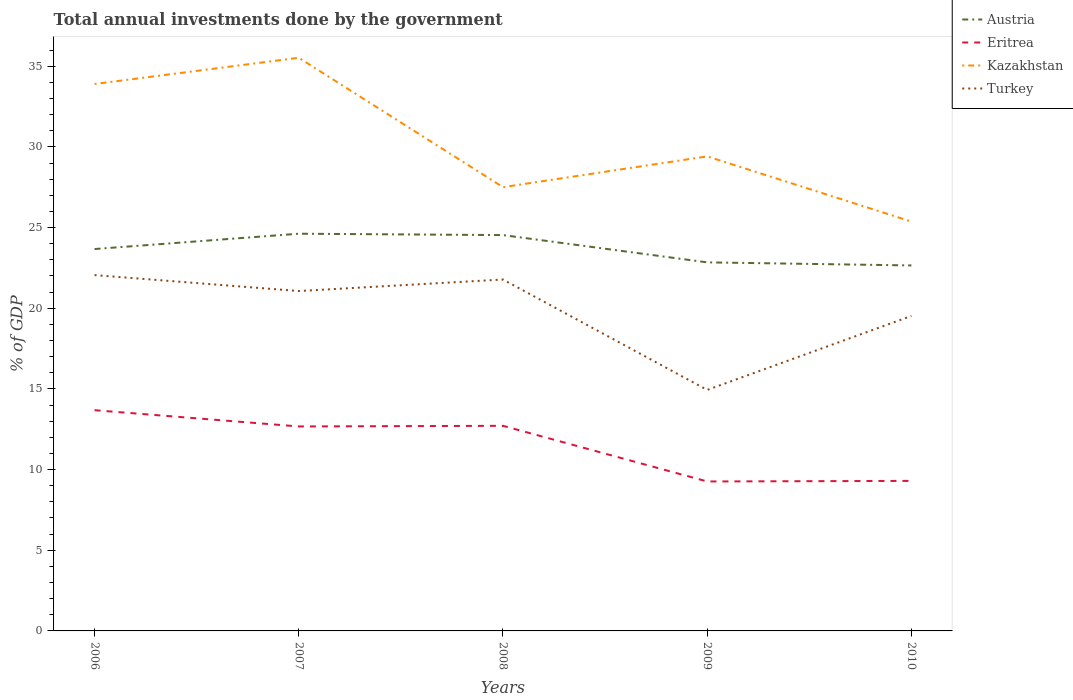How many different coloured lines are there?
Keep it short and to the point. 4. Is the number of lines equal to the number of legend labels?
Give a very brief answer. Yes. Across all years, what is the maximum total annual investments done by the government in Kazakhstan?
Offer a very short reply. 25.37. What is the total total annual investments done by the government in Eritrea in the graph?
Provide a succinct answer. 0.97. What is the difference between the highest and the second highest total annual investments done by the government in Kazakhstan?
Your answer should be very brief. 10.15. What is the difference between the highest and the lowest total annual investments done by the government in Kazakhstan?
Give a very brief answer. 2. How many lines are there?
Your answer should be very brief. 4. How many years are there in the graph?
Offer a terse response. 5. Are the values on the major ticks of Y-axis written in scientific E-notation?
Your answer should be compact. No. Where does the legend appear in the graph?
Make the answer very short. Top right. What is the title of the graph?
Provide a short and direct response. Total annual investments done by the government. What is the label or title of the Y-axis?
Offer a terse response. % of GDP. What is the % of GDP of Austria in 2006?
Provide a succinct answer. 23.67. What is the % of GDP in Eritrea in 2006?
Keep it short and to the point. 13.68. What is the % of GDP of Kazakhstan in 2006?
Keep it short and to the point. 33.9. What is the % of GDP of Turkey in 2006?
Offer a terse response. 22.05. What is the % of GDP in Austria in 2007?
Your answer should be compact. 24.62. What is the % of GDP in Eritrea in 2007?
Provide a short and direct response. 12.67. What is the % of GDP of Kazakhstan in 2007?
Give a very brief answer. 35.53. What is the % of GDP in Turkey in 2007?
Your answer should be very brief. 21.07. What is the % of GDP of Austria in 2008?
Give a very brief answer. 24.54. What is the % of GDP of Eritrea in 2008?
Ensure brevity in your answer.  12.71. What is the % of GDP of Kazakhstan in 2008?
Your answer should be very brief. 27.51. What is the % of GDP of Turkey in 2008?
Give a very brief answer. 21.78. What is the % of GDP in Austria in 2009?
Offer a very short reply. 22.84. What is the % of GDP of Eritrea in 2009?
Give a very brief answer. 9.26. What is the % of GDP of Kazakhstan in 2009?
Offer a very short reply. 29.41. What is the % of GDP of Turkey in 2009?
Make the answer very short. 14.94. What is the % of GDP of Austria in 2010?
Keep it short and to the point. 22.65. What is the % of GDP in Eritrea in 2010?
Give a very brief answer. 9.3. What is the % of GDP of Kazakhstan in 2010?
Your answer should be very brief. 25.37. What is the % of GDP of Turkey in 2010?
Provide a succinct answer. 19.52. Across all years, what is the maximum % of GDP of Austria?
Make the answer very short. 24.62. Across all years, what is the maximum % of GDP of Eritrea?
Give a very brief answer. 13.68. Across all years, what is the maximum % of GDP in Kazakhstan?
Offer a terse response. 35.53. Across all years, what is the maximum % of GDP of Turkey?
Keep it short and to the point. 22.05. Across all years, what is the minimum % of GDP in Austria?
Provide a short and direct response. 22.65. Across all years, what is the minimum % of GDP in Eritrea?
Give a very brief answer. 9.26. Across all years, what is the minimum % of GDP of Kazakhstan?
Provide a short and direct response. 25.37. Across all years, what is the minimum % of GDP of Turkey?
Provide a short and direct response. 14.94. What is the total % of GDP of Austria in the graph?
Your response must be concise. 118.32. What is the total % of GDP in Eritrea in the graph?
Your response must be concise. 57.63. What is the total % of GDP in Kazakhstan in the graph?
Your response must be concise. 151.72. What is the total % of GDP of Turkey in the graph?
Offer a terse response. 99.37. What is the difference between the % of GDP of Austria in 2006 and that in 2007?
Make the answer very short. -0.95. What is the difference between the % of GDP in Eritrea in 2006 and that in 2007?
Your response must be concise. 1.01. What is the difference between the % of GDP of Kazakhstan in 2006 and that in 2007?
Provide a short and direct response. -1.63. What is the difference between the % of GDP of Turkey in 2006 and that in 2007?
Ensure brevity in your answer.  0.99. What is the difference between the % of GDP in Austria in 2006 and that in 2008?
Ensure brevity in your answer.  -0.87. What is the difference between the % of GDP of Eritrea in 2006 and that in 2008?
Ensure brevity in your answer.  0.97. What is the difference between the % of GDP in Kazakhstan in 2006 and that in 2008?
Give a very brief answer. 6.39. What is the difference between the % of GDP in Turkey in 2006 and that in 2008?
Ensure brevity in your answer.  0.27. What is the difference between the % of GDP in Austria in 2006 and that in 2009?
Provide a short and direct response. 0.83. What is the difference between the % of GDP of Eritrea in 2006 and that in 2009?
Your response must be concise. 4.42. What is the difference between the % of GDP in Kazakhstan in 2006 and that in 2009?
Offer a very short reply. 4.49. What is the difference between the % of GDP of Turkey in 2006 and that in 2009?
Ensure brevity in your answer.  7.12. What is the difference between the % of GDP in Austria in 2006 and that in 2010?
Your answer should be very brief. 1.02. What is the difference between the % of GDP in Eritrea in 2006 and that in 2010?
Ensure brevity in your answer.  4.38. What is the difference between the % of GDP in Kazakhstan in 2006 and that in 2010?
Provide a succinct answer. 8.53. What is the difference between the % of GDP in Turkey in 2006 and that in 2010?
Offer a terse response. 2.53. What is the difference between the % of GDP in Austria in 2007 and that in 2008?
Ensure brevity in your answer.  0.08. What is the difference between the % of GDP in Eritrea in 2007 and that in 2008?
Offer a very short reply. -0.04. What is the difference between the % of GDP in Kazakhstan in 2007 and that in 2008?
Your answer should be compact. 8.02. What is the difference between the % of GDP of Turkey in 2007 and that in 2008?
Offer a very short reply. -0.71. What is the difference between the % of GDP in Austria in 2007 and that in 2009?
Provide a succinct answer. 1.78. What is the difference between the % of GDP in Eritrea in 2007 and that in 2009?
Your answer should be very brief. 3.41. What is the difference between the % of GDP in Kazakhstan in 2007 and that in 2009?
Give a very brief answer. 6.11. What is the difference between the % of GDP in Turkey in 2007 and that in 2009?
Offer a terse response. 6.13. What is the difference between the % of GDP in Austria in 2007 and that in 2010?
Provide a succinct answer. 1.97. What is the difference between the % of GDP in Eritrea in 2007 and that in 2010?
Give a very brief answer. 3.37. What is the difference between the % of GDP in Kazakhstan in 2007 and that in 2010?
Provide a succinct answer. 10.15. What is the difference between the % of GDP of Turkey in 2007 and that in 2010?
Provide a short and direct response. 1.54. What is the difference between the % of GDP in Austria in 2008 and that in 2009?
Your answer should be compact. 1.69. What is the difference between the % of GDP of Eritrea in 2008 and that in 2009?
Provide a short and direct response. 3.45. What is the difference between the % of GDP in Kazakhstan in 2008 and that in 2009?
Offer a terse response. -1.91. What is the difference between the % of GDP of Turkey in 2008 and that in 2009?
Your response must be concise. 6.84. What is the difference between the % of GDP of Austria in 2008 and that in 2010?
Provide a short and direct response. 1.88. What is the difference between the % of GDP in Eritrea in 2008 and that in 2010?
Your answer should be compact. 3.41. What is the difference between the % of GDP of Kazakhstan in 2008 and that in 2010?
Offer a very short reply. 2.13. What is the difference between the % of GDP in Turkey in 2008 and that in 2010?
Your response must be concise. 2.26. What is the difference between the % of GDP of Austria in 2009 and that in 2010?
Ensure brevity in your answer.  0.19. What is the difference between the % of GDP in Eritrea in 2009 and that in 2010?
Your response must be concise. -0.04. What is the difference between the % of GDP in Kazakhstan in 2009 and that in 2010?
Ensure brevity in your answer.  4.04. What is the difference between the % of GDP in Turkey in 2009 and that in 2010?
Provide a succinct answer. -4.59. What is the difference between the % of GDP of Austria in 2006 and the % of GDP of Eritrea in 2007?
Ensure brevity in your answer.  11. What is the difference between the % of GDP of Austria in 2006 and the % of GDP of Kazakhstan in 2007?
Keep it short and to the point. -11.86. What is the difference between the % of GDP of Austria in 2006 and the % of GDP of Turkey in 2007?
Give a very brief answer. 2.6. What is the difference between the % of GDP of Eritrea in 2006 and the % of GDP of Kazakhstan in 2007?
Provide a short and direct response. -21.85. What is the difference between the % of GDP in Eritrea in 2006 and the % of GDP in Turkey in 2007?
Provide a short and direct response. -7.39. What is the difference between the % of GDP of Kazakhstan in 2006 and the % of GDP of Turkey in 2007?
Make the answer very short. 12.83. What is the difference between the % of GDP of Austria in 2006 and the % of GDP of Eritrea in 2008?
Provide a succinct answer. 10.96. What is the difference between the % of GDP of Austria in 2006 and the % of GDP of Kazakhstan in 2008?
Offer a terse response. -3.84. What is the difference between the % of GDP of Austria in 2006 and the % of GDP of Turkey in 2008?
Make the answer very short. 1.89. What is the difference between the % of GDP in Eritrea in 2006 and the % of GDP in Kazakhstan in 2008?
Make the answer very short. -13.83. What is the difference between the % of GDP in Eritrea in 2006 and the % of GDP in Turkey in 2008?
Provide a succinct answer. -8.1. What is the difference between the % of GDP in Kazakhstan in 2006 and the % of GDP in Turkey in 2008?
Offer a terse response. 12.12. What is the difference between the % of GDP in Austria in 2006 and the % of GDP in Eritrea in 2009?
Keep it short and to the point. 14.41. What is the difference between the % of GDP in Austria in 2006 and the % of GDP in Kazakhstan in 2009?
Give a very brief answer. -5.74. What is the difference between the % of GDP of Austria in 2006 and the % of GDP of Turkey in 2009?
Your answer should be compact. 8.73. What is the difference between the % of GDP in Eritrea in 2006 and the % of GDP in Kazakhstan in 2009?
Your answer should be compact. -15.73. What is the difference between the % of GDP of Eritrea in 2006 and the % of GDP of Turkey in 2009?
Give a very brief answer. -1.26. What is the difference between the % of GDP of Kazakhstan in 2006 and the % of GDP of Turkey in 2009?
Ensure brevity in your answer.  18.96. What is the difference between the % of GDP in Austria in 2006 and the % of GDP in Eritrea in 2010?
Make the answer very short. 14.37. What is the difference between the % of GDP of Austria in 2006 and the % of GDP of Kazakhstan in 2010?
Offer a terse response. -1.7. What is the difference between the % of GDP of Austria in 2006 and the % of GDP of Turkey in 2010?
Your answer should be compact. 4.15. What is the difference between the % of GDP of Eritrea in 2006 and the % of GDP of Kazakhstan in 2010?
Ensure brevity in your answer.  -11.69. What is the difference between the % of GDP in Eritrea in 2006 and the % of GDP in Turkey in 2010?
Make the answer very short. -5.84. What is the difference between the % of GDP of Kazakhstan in 2006 and the % of GDP of Turkey in 2010?
Your answer should be compact. 14.38. What is the difference between the % of GDP in Austria in 2007 and the % of GDP in Eritrea in 2008?
Keep it short and to the point. 11.91. What is the difference between the % of GDP in Austria in 2007 and the % of GDP in Kazakhstan in 2008?
Keep it short and to the point. -2.89. What is the difference between the % of GDP in Austria in 2007 and the % of GDP in Turkey in 2008?
Your answer should be very brief. 2.84. What is the difference between the % of GDP of Eritrea in 2007 and the % of GDP of Kazakhstan in 2008?
Your answer should be compact. -14.83. What is the difference between the % of GDP of Eritrea in 2007 and the % of GDP of Turkey in 2008?
Provide a succinct answer. -9.11. What is the difference between the % of GDP in Kazakhstan in 2007 and the % of GDP in Turkey in 2008?
Your response must be concise. 13.74. What is the difference between the % of GDP of Austria in 2007 and the % of GDP of Eritrea in 2009?
Your response must be concise. 15.36. What is the difference between the % of GDP of Austria in 2007 and the % of GDP of Kazakhstan in 2009?
Give a very brief answer. -4.79. What is the difference between the % of GDP in Austria in 2007 and the % of GDP in Turkey in 2009?
Provide a succinct answer. 9.68. What is the difference between the % of GDP in Eritrea in 2007 and the % of GDP in Kazakhstan in 2009?
Your answer should be very brief. -16.74. What is the difference between the % of GDP of Eritrea in 2007 and the % of GDP of Turkey in 2009?
Make the answer very short. -2.26. What is the difference between the % of GDP of Kazakhstan in 2007 and the % of GDP of Turkey in 2009?
Provide a short and direct response. 20.59. What is the difference between the % of GDP of Austria in 2007 and the % of GDP of Eritrea in 2010?
Keep it short and to the point. 15.32. What is the difference between the % of GDP in Austria in 2007 and the % of GDP in Kazakhstan in 2010?
Make the answer very short. -0.75. What is the difference between the % of GDP in Austria in 2007 and the % of GDP in Turkey in 2010?
Provide a short and direct response. 5.1. What is the difference between the % of GDP of Eritrea in 2007 and the % of GDP of Turkey in 2010?
Offer a terse response. -6.85. What is the difference between the % of GDP in Kazakhstan in 2007 and the % of GDP in Turkey in 2010?
Offer a very short reply. 16. What is the difference between the % of GDP of Austria in 2008 and the % of GDP of Eritrea in 2009?
Offer a terse response. 15.27. What is the difference between the % of GDP of Austria in 2008 and the % of GDP of Kazakhstan in 2009?
Ensure brevity in your answer.  -4.88. What is the difference between the % of GDP in Austria in 2008 and the % of GDP in Turkey in 2009?
Make the answer very short. 9.6. What is the difference between the % of GDP of Eritrea in 2008 and the % of GDP of Kazakhstan in 2009?
Provide a succinct answer. -16.7. What is the difference between the % of GDP of Eritrea in 2008 and the % of GDP of Turkey in 2009?
Offer a terse response. -2.22. What is the difference between the % of GDP of Kazakhstan in 2008 and the % of GDP of Turkey in 2009?
Provide a succinct answer. 12.57. What is the difference between the % of GDP in Austria in 2008 and the % of GDP in Eritrea in 2010?
Provide a succinct answer. 15.24. What is the difference between the % of GDP of Austria in 2008 and the % of GDP of Kazakhstan in 2010?
Offer a terse response. -0.84. What is the difference between the % of GDP in Austria in 2008 and the % of GDP in Turkey in 2010?
Your answer should be compact. 5.01. What is the difference between the % of GDP of Eritrea in 2008 and the % of GDP of Kazakhstan in 2010?
Your answer should be very brief. -12.66. What is the difference between the % of GDP in Eritrea in 2008 and the % of GDP in Turkey in 2010?
Your response must be concise. -6.81. What is the difference between the % of GDP of Kazakhstan in 2008 and the % of GDP of Turkey in 2010?
Your answer should be compact. 7.98. What is the difference between the % of GDP of Austria in 2009 and the % of GDP of Eritrea in 2010?
Offer a terse response. 13.55. What is the difference between the % of GDP of Austria in 2009 and the % of GDP of Kazakhstan in 2010?
Make the answer very short. -2.53. What is the difference between the % of GDP in Austria in 2009 and the % of GDP in Turkey in 2010?
Your answer should be very brief. 3.32. What is the difference between the % of GDP in Eritrea in 2009 and the % of GDP in Kazakhstan in 2010?
Give a very brief answer. -16.11. What is the difference between the % of GDP of Eritrea in 2009 and the % of GDP of Turkey in 2010?
Your answer should be compact. -10.26. What is the difference between the % of GDP in Kazakhstan in 2009 and the % of GDP in Turkey in 2010?
Provide a short and direct response. 9.89. What is the average % of GDP of Austria per year?
Make the answer very short. 23.66. What is the average % of GDP of Eritrea per year?
Offer a very short reply. 11.53. What is the average % of GDP of Kazakhstan per year?
Your answer should be compact. 30.34. What is the average % of GDP in Turkey per year?
Provide a short and direct response. 19.87. In the year 2006, what is the difference between the % of GDP of Austria and % of GDP of Eritrea?
Make the answer very short. 9.99. In the year 2006, what is the difference between the % of GDP in Austria and % of GDP in Kazakhstan?
Your response must be concise. -10.23. In the year 2006, what is the difference between the % of GDP in Austria and % of GDP in Turkey?
Offer a very short reply. 1.62. In the year 2006, what is the difference between the % of GDP of Eritrea and % of GDP of Kazakhstan?
Give a very brief answer. -20.22. In the year 2006, what is the difference between the % of GDP in Eritrea and % of GDP in Turkey?
Give a very brief answer. -8.37. In the year 2006, what is the difference between the % of GDP of Kazakhstan and % of GDP of Turkey?
Ensure brevity in your answer.  11.85. In the year 2007, what is the difference between the % of GDP of Austria and % of GDP of Eritrea?
Offer a terse response. 11.95. In the year 2007, what is the difference between the % of GDP of Austria and % of GDP of Kazakhstan?
Offer a very short reply. -10.91. In the year 2007, what is the difference between the % of GDP of Austria and % of GDP of Turkey?
Provide a short and direct response. 3.55. In the year 2007, what is the difference between the % of GDP of Eritrea and % of GDP of Kazakhstan?
Ensure brevity in your answer.  -22.85. In the year 2007, what is the difference between the % of GDP of Eritrea and % of GDP of Turkey?
Keep it short and to the point. -8.39. In the year 2007, what is the difference between the % of GDP of Kazakhstan and % of GDP of Turkey?
Your answer should be compact. 14.46. In the year 2008, what is the difference between the % of GDP in Austria and % of GDP in Eritrea?
Provide a short and direct response. 11.82. In the year 2008, what is the difference between the % of GDP in Austria and % of GDP in Kazakhstan?
Provide a succinct answer. -2.97. In the year 2008, what is the difference between the % of GDP of Austria and % of GDP of Turkey?
Give a very brief answer. 2.75. In the year 2008, what is the difference between the % of GDP in Eritrea and % of GDP in Kazakhstan?
Your answer should be compact. -14.79. In the year 2008, what is the difference between the % of GDP in Eritrea and % of GDP in Turkey?
Keep it short and to the point. -9.07. In the year 2008, what is the difference between the % of GDP of Kazakhstan and % of GDP of Turkey?
Keep it short and to the point. 5.72. In the year 2009, what is the difference between the % of GDP in Austria and % of GDP in Eritrea?
Offer a terse response. 13.58. In the year 2009, what is the difference between the % of GDP in Austria and % of GDP in Kazakhstan?
Your answer should be very brief. -6.57. In the year 2009, what is the difference between the % of GDP in Austria and % of GDP in Turkey?
Offer a very short reply. 7.91. In the year 2009, what is the difference between the % of GDP in Eritrea and % of GDP in Kazakhstan?
Provide a short and direct response. -20.15. In the year 2009, what is the difference between the % of GDP of Eritrea and % of GDP of Turkey?
Offer a very short reply. -5.67. In the year 2009, what is the difference between the % of GDP in Kazakhstan and % of GDP in Turkey?
Give a very brief answer. 14.48. In the year 2010, what is the difference between the % of GDP of Austria and % of GDP of Eritrea?
Offer a very short reply. 13.35. In the year 2010, what is the difference between the % of GDP in Austria and % of GDP in Kazakhstan?
Provide a succinct answer. -2.72. In the year 2010, what is the difference between the % of GDP of Austria and % of GDP of Turkey?
Give a very brief answer. 3.13. In the year 2010, what is the difference between the % of GDP of Eritrea and % of GDP of Kazakhstan?
Make the answer very short. -16.07. In the year 2010, what is the difference between the % of GDP in Eritrea and % of GDP in Turkey?
Make the answer very short. -10.22. In the year 2010, what is the difference between the % of GDP of Kazakhstan and % of GDP of Turkey?
Give a very brief answer. 5.85. What is the ratio of the % of GDP in Austria in 2006 to that in 2007?
Your answer should be very brief. 0.96. What is the ratio of the % of GDP in Eritrea in 2006 to that in 2007?
Your answer should be very brief. 1.08. What is the ratio of the % of GDP of Kazakhstan in 2006 to that in 2007?
Make the answer very short. 0.95. What is the ratio of the % of GDP of Turkey in 2006 to that in 2007?
Make the answer very short. 1.05. What is the ratio of the % of GDP in Austria in 2006 to that in 2008?
Provide a succinct answer. 0.96. What is the ratio of the % of GDP of Eritrea in 2006 to that in 2008?
Make the answer very short. 1.08. What is the ratio of the % of GDP in Kazakhstan in 2006 to that in 2008?
Give a very brief answer. 1.23. What is the ratio of the % of GDP in Turkey in 2006 to that in 2008?
Your answer should be compact. 1.01. What is the ratio of the % of GDP of Austria in 2006 to that in 2009?
Your answer should be very brief. 1.04. What is the ratio of the % of GDP of Eritrea in 2006 to that in 2009?
Make the answer very short. 1.48. What is the ratio of the % of GDP of Kazakhstan in 2006 to that in 2009?
Ensure brevity in your answer.  1.15. What is the ratio of the % of GDP in Turkey in 2006 to that in 2009?
Your answer should be very brief. 1.48. What is the ratio of the % of GDP in Austria in 2006 to that in 2010?
Your response must be concise. 1.04. What is the ratio of the % of GDP of Eritrea in 2006 to that in 2010?
Ensure brevity in your answer.  1.47. What is the ratio of the % of GDP in Kazakhstan in 2006 to that in 2010?
Give a very brief answer. 1.34. What is the ratio of the % of GDP in Turkey in 2006 to that in 2010?
Offer a very short reply. 1.13. What is the ratio of the % of GDP in Austria in 2007 to that in 2008?
Make the answer very short. 1. What is the ratio of the % of GDP of Eritrea in 2007 to that in 2008?
Your answer should be very brief. 1. What is the ratio of the % of GDP of Kazakhstan in 2007 to that in 2008?
Give a very brief answer. 1.29. What is the ratio of the % of GDP in Turkey in 2007 to that in 2008?
Provide a short and direct response. 0.97. What is the ratio of the % of GDP of Austria in 2007 to that in 2009?
Keep it short and to the point. 1.08. What is the ratio of the % of GDP in Eritrea in 2007 to that in 2009?
Offer a very short reply. 1.37. What is the ratio of the % of GDP of Kazakhstan in 2007 to that in 2009?
Make the answer very short. 1.21. What is the ratio of the % of GDP of Turkey in 2007 to that in 2009?
Keep it short and to the point. 1.41. What is the ratio of the % of GDP of Austria in 2007 to that in 2010?
Offer a terse response. 1.09. What is the ratio of the % of GDP in Eritrea in 2007 to that in 2010?
Make the answer very short. 1.36. What is the ratio of the % of GDP of Kazakhstan in 2007 to that in 2010?
Keep it short and to the point. 1.4. What is the ratio of the % of GDP in Turkey in 2007 to that in 2010?
Offer a very short reply. 1.08. What is the ratio of the % of GDP in Austria in 2008 to that in 2009?
Ensure brevity in your answer.  1.07. What is the ratio of the % of GDP in Eritrea in 2008 to that in 2009?
Offer a terse response. 1.37. What is the ratio of the % of GDP in Kazakhstan in 2008 to that in 2009?
Provide a succinct answer. 0.94. What is the ratio of the % of GDP of Turkey in 2008 to that in 2009?
Make the answer very short. 1.46. What is the ratio of the % of GDP of Austria in 2008 to that in 2010?
Your response must be concise. 1.08. What is the ratio of the % of GDP in Eritrea in 2008 to that in 2010?
Provide a short and direct response. 1.37. What is the ratio of the % of GDP in Kazakhstan in 2008 to that in 2010?
Make the answer very short. 1.08. What is the ratio of the % of GDP in Turkey in 2008 to that in 2010?
Provide a short and direct response. 1.12. What is the ratio of the % of GDP in Austria in 2009 to that in 2010?
Your response must be concise. 1.01. What is the ratio of the % of GDP in Kazakhstan in 2009 to that in 2010?
Make the answer very short. 1.16. What is the ratio of the % of GDP in Turkey in 2009 to that in 2010?
Make the answer very short. 0.77. What is the difference between the highest and the second highest % of GDP in Austria?
Your response must be concise. 0.08. What is the difference between the highest and the second highest % of GDP in Eritrea?
Offer a very short reply. 0.97. What is the difference between the highest and the second highest % of GDP in Kazakhstan?
Your answer should be very brief. 1.63. What is the difference between the highest and the second highest % of GDP of Turkey?
Keep it short and to the point. 0.27. What is the difference between the highest and the lowest % of GDP in Austria?
Offer a terse response. 1.97. What is the difference between the highest and the lowest % of GDP of Eritrea?
Offer a terse response. 4.42. What is the difference between the highest and the lowest % of GDP of Kazakhstan?
Provide a succinct answer. 10.15. What is the difference between the highest and the lowest % of GDP in Turkey?
Provide a short and direct response. 7.12. 